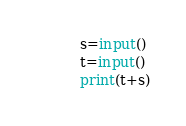<code> <loc_0><loc_0><loc_500><loc_500><_Python_>s=input()
t=input()
print(t+s)</code> 